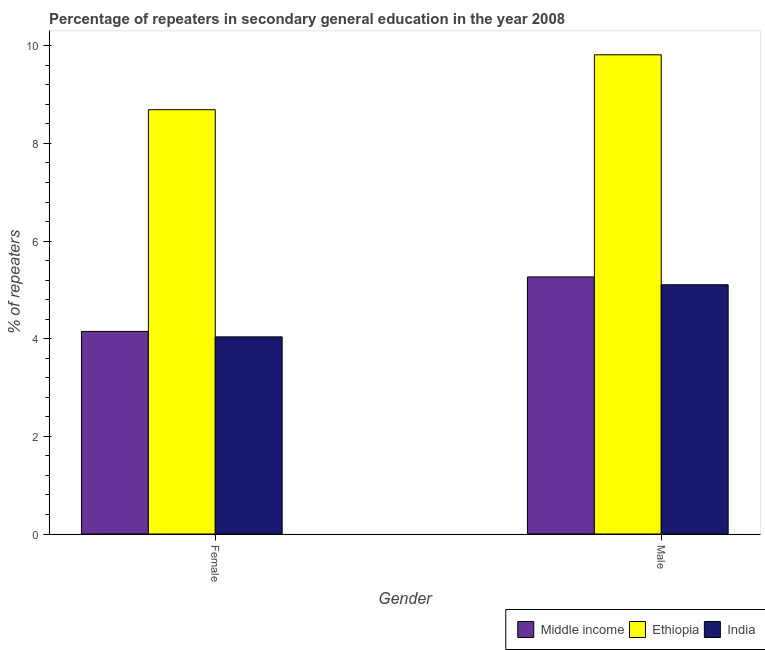How many different coloured bars are there?
Your response must be concise. 3. Are the number of bars per tick equal to the number of legend labels?
Ensure brevity in your answer.  Yes. How many bars are there on the 1st tick from the left?
Offer a very short reply. 3. What is the label of the 2nd group of bars from the left?
Ensure brevity in your answer.  Male. What is the percentage of female repeaters in Middle income?
Your answer should be very brief. 4.15. Across all countries, what is the maximum percentage of female repeaters?
Keep it short and to the point. 8.69. Across all countries, what is the minimum percentage of male repeaters?
Keep it short and to the point. 5.1. In which country was the percentage of female repeaters maximum?
Your response must be concise. Ethiopia. In which country was the percentage of female repeaters minimum?
Your response must be concise. India. What is the total percentage of male repeaters in the graph?
Provide a short and direct response. 20.19. What is the difference between the percentage of male repeaters in India and that in Ethiopia?
Your answer should be compact. -4.71. What is the difference between the percentage of male repeaters in Middle income and the percentage of female repeaters in Ethiopia?
Your answer should be compact. -3.43. What is the average percentage of male repeaters per country?
Make the answer very short. 6.73. What is the difference between the percentage of female repeaters and percentage of male repeaters in India?
Keep it short and to the point. -1.07. In how many countries, is the percentage of female repeaters greater than 6.8 %?
Offer a terse response. 1. What is the ratio of the percentage of male repeaters in Middle income to that in Ethiopia?
Your answer should be very brief. 0.54. Is the percentage of male repeaters in India less than that in Ethiopia?
Give a very brief answer. Yes. In how many countries, is the percentage of male repeaters greater than the average percentage of male repeaters taken over all countries?
Offer a terse response. 1. What does the 2nd bar from the left in Female represents?
Make the answer very short. Ethiopia. What does the 2nd bar from the right in Male represents?
Give a very brief answer. Ethiopia. Are all the bars in the graph horizontal?
Keep it short and to the point. No. Does the graph contain any zero values?
Give a very brief answer. No. What is the title of the graph?
Your answer should be very brief. Percentage of repeaters in secondary general education in the year 2008. Does "Lesotho" appear as one of the legend labels in the graph?
Ensure brevity in your answer.  No. What is the label or title of the X-axis?
Offer a very short reply. Gender. What is the label or title of the Y-axis?
Provide a short and direct response. % of repeaters. What is the % of repeaters in Middle income in Female?
Keep it short and to the point. 4.15. What is the % of repeaters in Ethiopia in Female?
Ensure brevity in your answer.  8.69. What is the % of repeaters of India in Female?
Keep it short and to the point. 4.04. What is the % of repeaters in Middle income in Male?
Keep it short and to the point. 5.27. What is the % of repeaters in Ethiopia in Male?
Ensure brevity in your answer.  9.82. What is the % of repeaters of India in Male?
Your answer should be compact. 5.1. Across all Gender, what is the maximum % of repeaters in Middle income?
Your answer should be very brief. 5.27. Across all Gender, what is the maximum % of repeaters in Ethiopia?
Offer a terse response. 9.82. Across all Gender, what is the maximum % of repeaters of India?
Your response must be concise. 5.1. Across all Gender, what is the minimum % of repeaters of Middle income?
Provide a succinct answer. 4.15. Across all Gender, what is the minimum % of repeaters in Ethiopia?
Your answer should be compact. 8.69. Across all Gender, what is the minimum % of repeaters of India?
Offer a terse response. 4.04. What is the total % of repeaters of Middle income in the graph?
Provide a succinct answer. 9.41. What is the total % of repeaters of Ethiopia in the graph?
Offer a very short reply. 18.51. What is the total % of repeaters of India in the graph?
Give a very brief answer. 9.14. What is the difference between the % of repeaters in Middle income in Female and that in Male?
Give a very brief answer. -1.12. What is the difference between the % of repeaters in Ethiopia in Female and that in Male?
Your response must be concise. -1.12. What is the difference between the % of repeaters in India in Female and that in Male?
Give a very brief answer. -1.07. What is the difference between the % of repeaters of Middle income in Female and the % of repeaters of Ethiopia in Male?
Your response must be concise. -5.67. What is the difference between the % of repeaters of Middle income in Female and the % of repeaters of India in Male?
Your answer should be compact. -0.96. What is the difference between the % of repeaters of Ethiopia in Female and the % of repeaters of India in Male?
Provide a short and direct response. 3.59. What is the average % of repeaters in Middle income per Gender?
Offer a terse response. 4.71. What is the average % of repeaters of Ethiopia per Gender?
Provide a succinct answer. 9.25. What is the average % of repeaters in India per Gender?
Your answer should be compact. 4.57. What is the difference between the % of repeaters of Middle income and % of repeaters of Ethiopia in Female?
Your answer should be very brief. -4.54. What is the difference between the % of repeaters of Middle income and % of repeaters of India in Female?
Make the answer very short. 0.11. What is the difference between the % of repeaters in Ethiopia and % of repeaters in India in Female?
Your answer should be compact. 4.65. What is the difference between the % of repeaters in Middle income and % of repeaters in Ethiopia in Male?
Keep it short and to the point. -4.55. What is the difference between the % of repeaters in Middle income and % of repeaters in India in Male?
Offer a very short reply. 0.16. What is the difference between the % of repeaters in Ethiopia and % of repeaters in India in Male?
Your answer should be compact. 4.71. What is the ratio of the % of repeaters in Middle income in Female to that in Male?
Provide a short and direct response. 0.79. What is the ratio of the % of repeaters of Ethiopia in Female to that in Male?
Make the answer very short. 0.89. What is the ratio of the % of repeaters of India in Female to that in Male?
Provide a succinct answer. 0.79. What is the difference between the highest and the second highest % of repeaters of Middle income?
Ensure brevity in your answer.  1.12. What is the difference between the highest and the second highest % of repeaters in Ethiopia?
Keep it short and to the point. 1.12. What is the difference between the highest and the second highest % of repeaters in India?
Your answer should be very brief. 1.07. What is the difference between the highest and the lowest % of repeaters of Middle income?
Provide a succinct answer. 1.12. What is the difference between the highest and the lowest % of repeaters of Ethiopia?
Your answer should be very brief. 1.12. What is the difference between the highest and the lowest % of repeaters in India?
Provide a succinct answer. 1.07. 